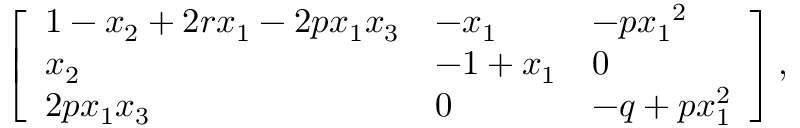<formula> <loc_0><loc_0><loc_500><loc_500>\left [ \begin{array} { l l l } { 1 - { x } _ { 2 } + 2 { r } { { x } _ { 1 } } - 2 { p } { { x } _ { 1 } } { { x } _ { 3 } } } & { { - { x } _ { 1 } } } & { { - p } { { x } _ { 1 } } ^ { 2 } } \\ { { { x } _ { 2 } } } & { { - 1 + { x } _ { 1 } } } & { 0 } \\ { 2 { p } { { x } _ { 1 } } { { x } _ { 3 } } } & { 0 } & { - q + { p } { x } _ { 1 } ^ { 2 } } \end{array} \right ] ,</formula> 